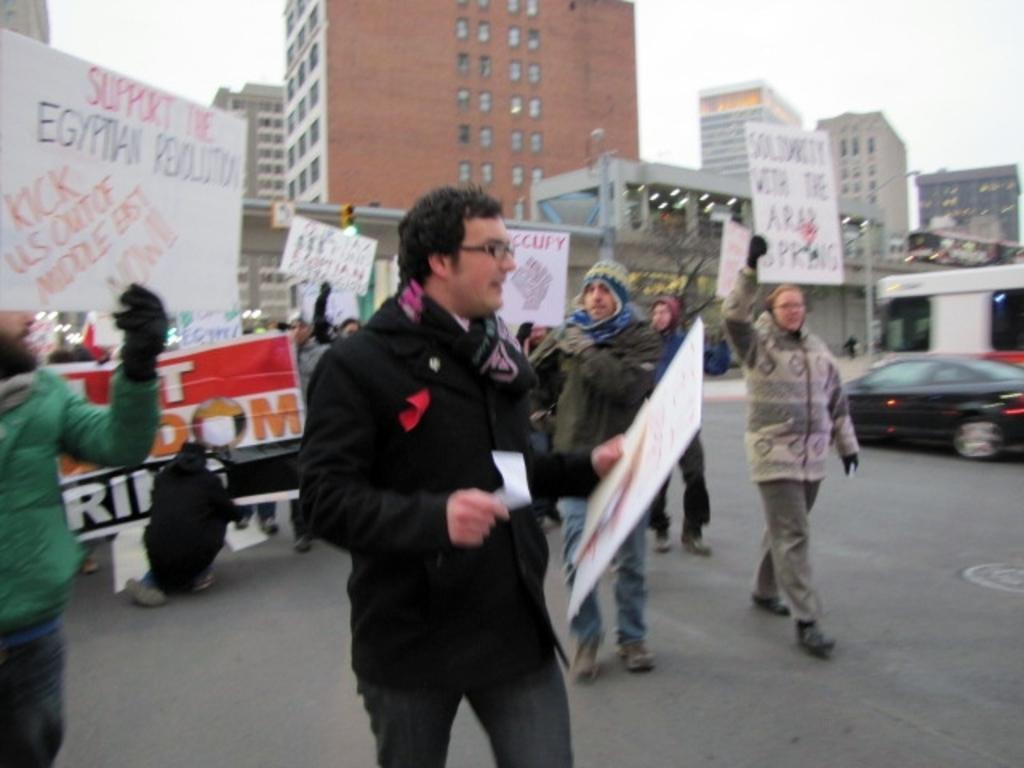Could you give a brief overview of what you see in this image? In this picture there are few persons standing and holding a card boards which has something written on it and there are buildings in the background. 